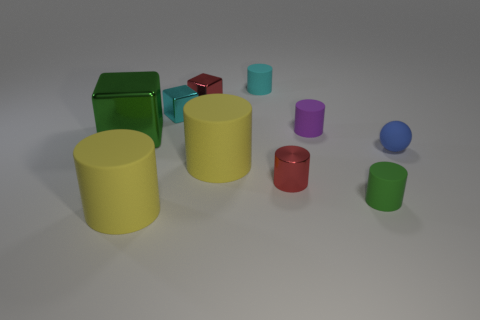Is there a tiny purple thing of the same shape as the tiny cyan metallic object? Yes, there is a tiny purple object that shares the cylindrical shape with the tiny cyan object, which appears to have a metallic finish. 